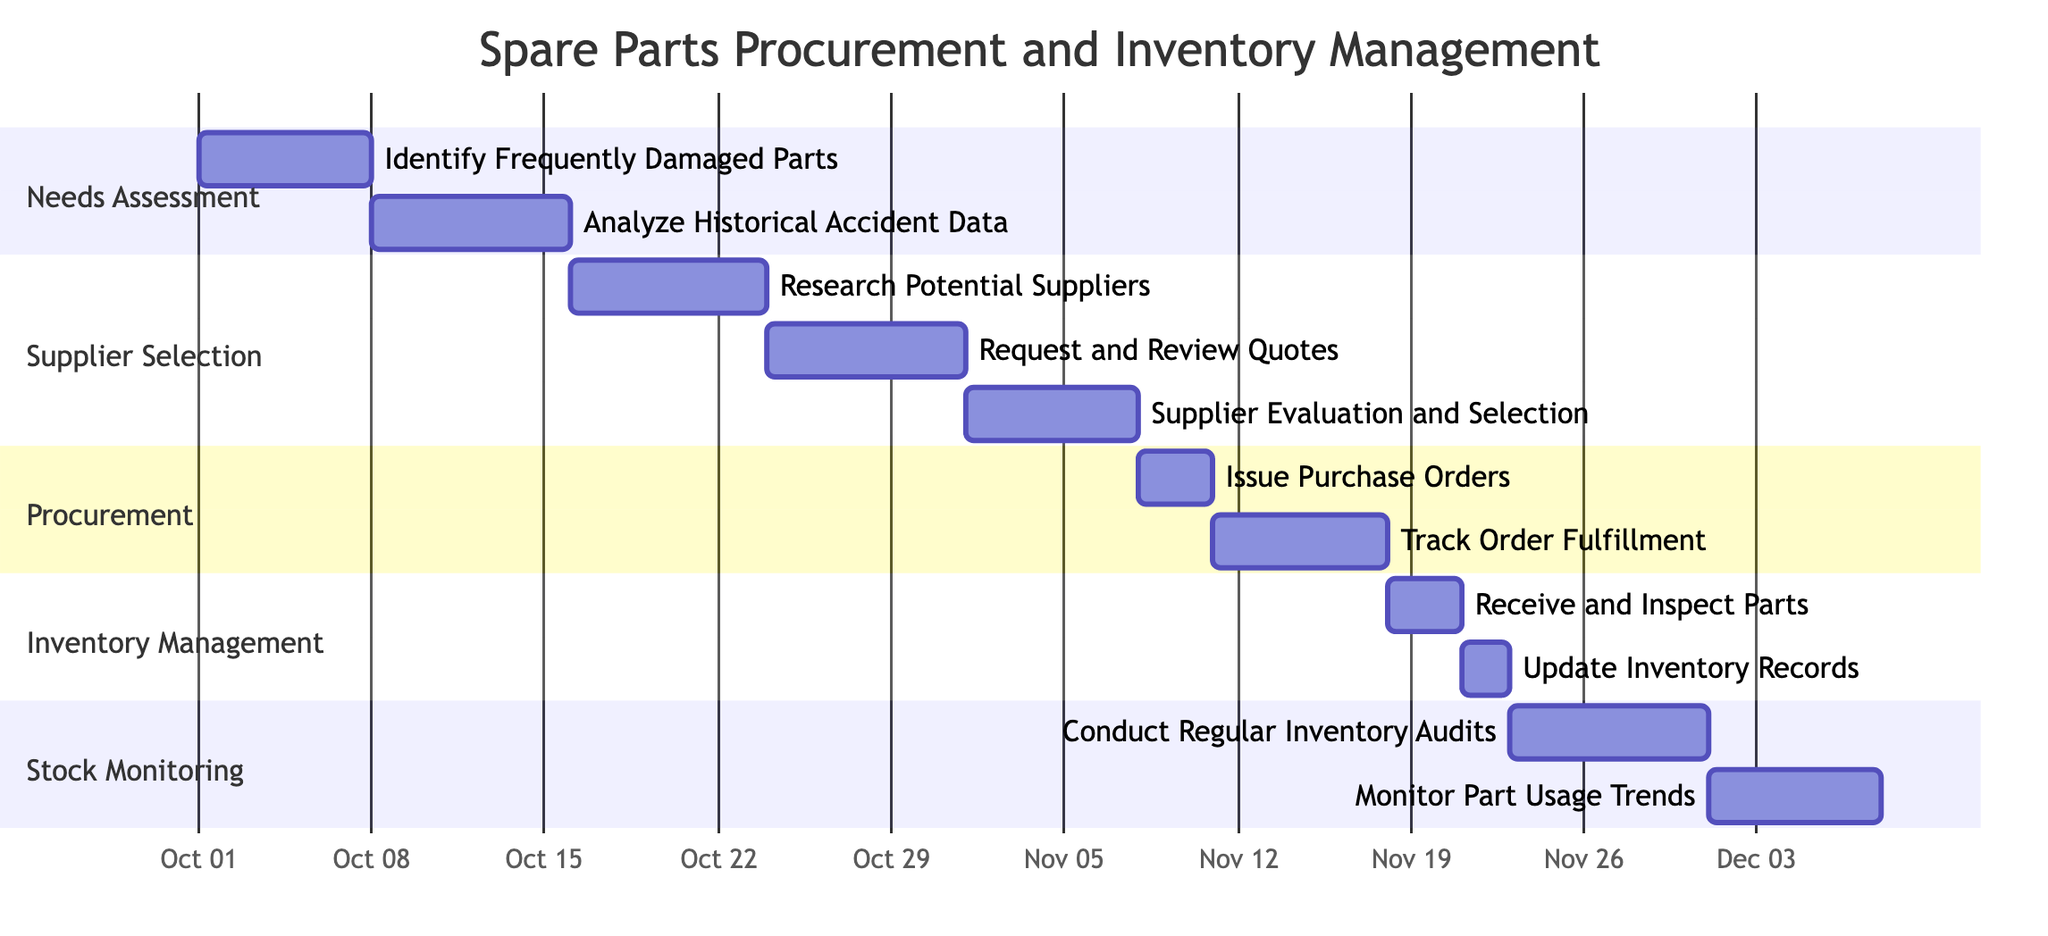What is the total number of phases in the diagram? The diagram contains five phases: Needs Assessment, Supplier Selection, Procurement, Inventory Management, and Stock Monitoring. By counting these phases, we find that there are a total of five.
Answer: 5 Which task occurs immediately after "Request and Review Quotes"? To determine the task that follows "Request and Review Quotes", we look at the sequence of tasks under the Supplier Selection phase. The task that comes next, immediately after it, is "Supplier Evaluation and Selection".
Answer: Supplier Evaluation and Selection What is the start date for "Receive and Inspect Parts"? We locate the task "Receive and Inspect Parts" within the Inventory Management section. According to the diagram, this task starts on November 18, 2023.
Answer: 2023-11-18 How many days does "Track Order Fulfillment" take? The "Track Order Fulfillment" task is shown to last for 7 days in the Procurement section. By reading the duration specified for this task, we confirm it takes seven days.
Answer: 7 days Which task has the longest duration in the Supplier Selection phase? We examine the durations of all tasks in the Supplier Selection phase. The task "Research Potential Suppliers" and "Request and Review Quotes" both last for 8 days, which is the longest duration among the tasks in this phase.
Answer: Research Potential Suppliers, Request and Review Quotes What is the relationship between "Conduct Regular Inventory Audits" and "Track Order Fulfillment"? To understand the relationship, we show that "Track Order Fulfillment" occurs in the Procurement phase and ends on November 17, 2023, while "Conduct Regular Inventory Audits" starts on November 23, 2023. Therefore, they are sequential, with "Track Order Fulfillment" occurring before "Conduct Regular Inventory Audits".
Answer: Sequential What is the end date for the "Analyze Historical Accident Data" task? The task "Analyze Historical Accident Data" starts on October 8, 2023, and lasts for 8 days. Therefore, by adding the duration to the start date, the end date is calculated to be October 15, 2023.
Answer: 2023-10-15 How many tasks are scheduled after the "Analyze Historical Accident Data"? After "Analyze Historical Accident Data", there are three tasks in the Supplier Selection phase: "Research Potential Suppliers", "Request and Review Quotes", and "Supplier Evaluation and Selection", totaling three tasks.
Answer: 3 Which phase starts immediately after Procurement? After the Procurement phase, the next phase listed is Inventory Management, which immediately follows Procurement. Therefore, we identify Inventory Management as the next phase.
Answer: Inventory Management 